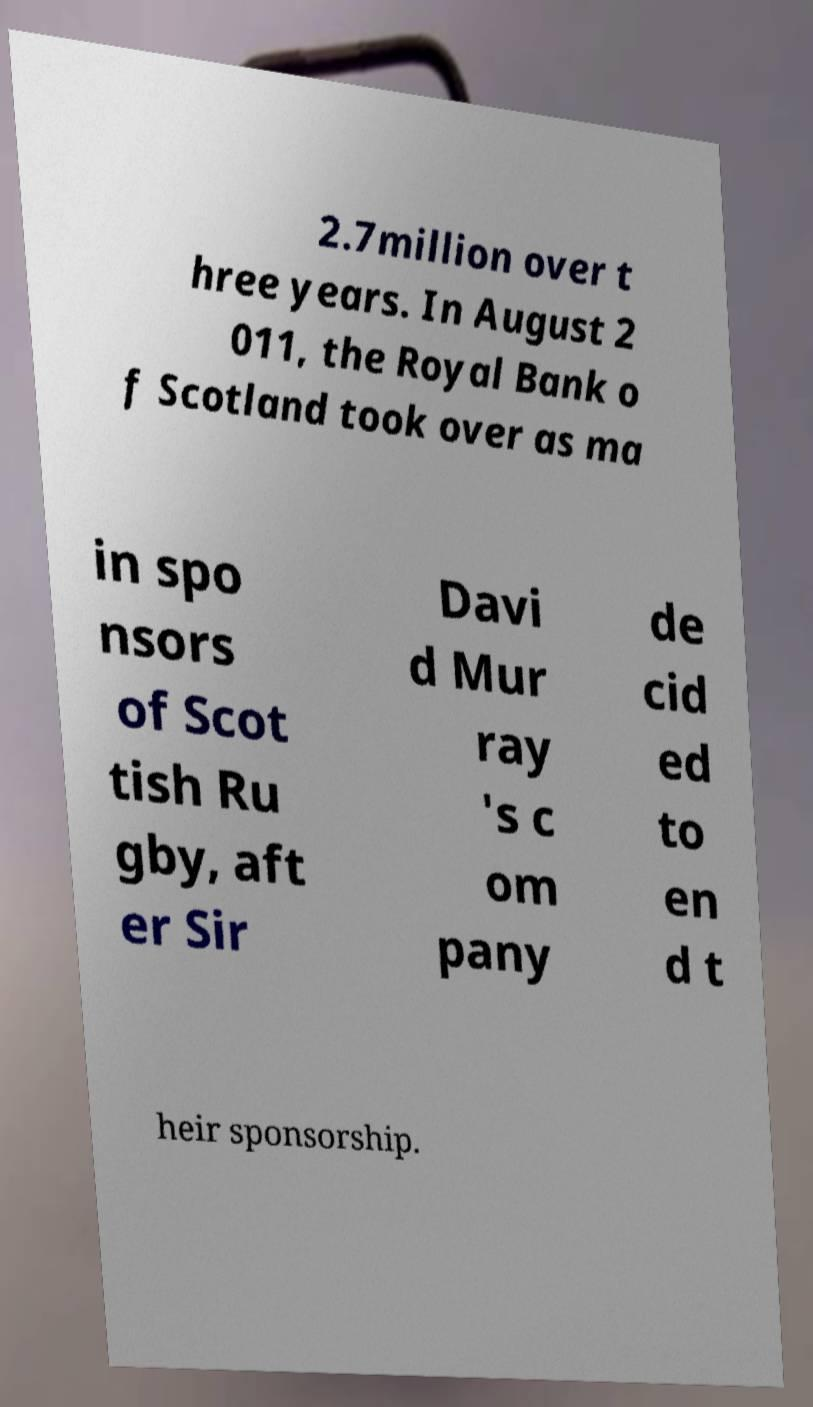For documentation purposes, I need the text within this image transcribed. Could you provide that? 2.7million over t hree years. In August 2 011, the Royal Bank o f Scotland took over as ma in spo nsors of Scot tish Ru gby, aft er Sir Davi d Mur ray 's c om pany de cid ed to en d t heir sponsorship. 